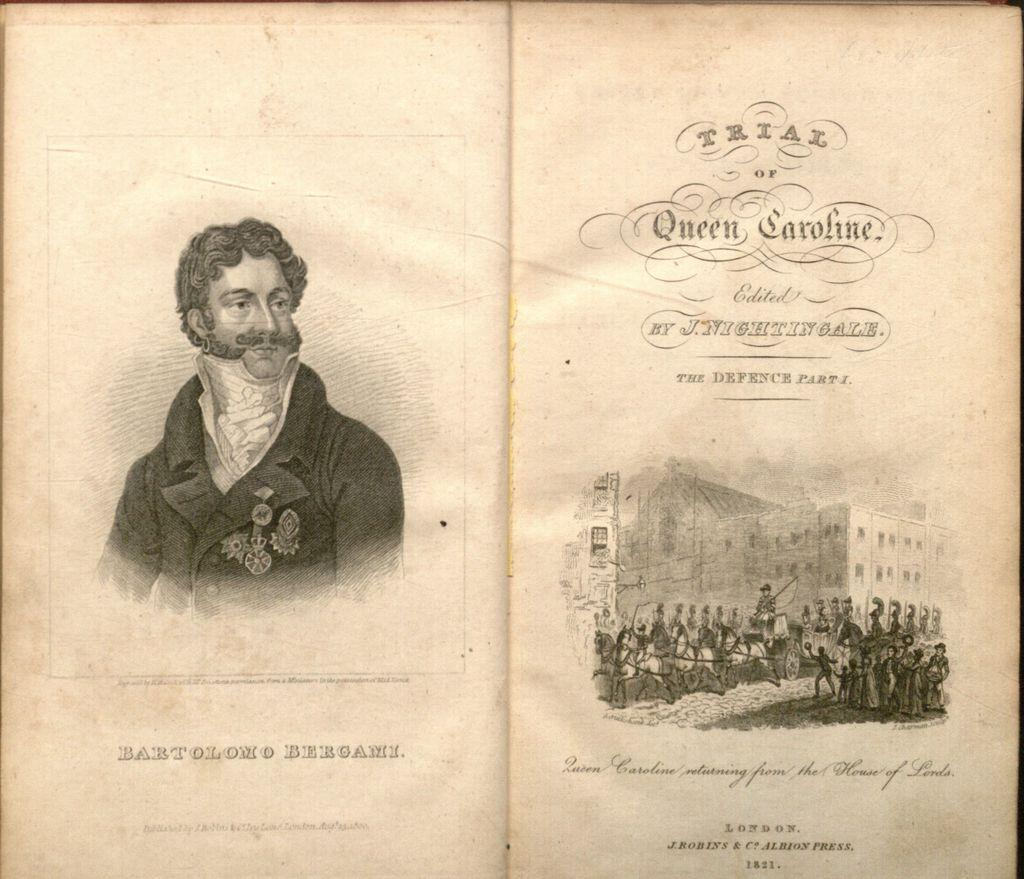What is located on the left side of the image? There is a person on the left side of the image. What can be seen on the right side of the image? There are people, trees, a vehicle, and a building on the right side of the image. How many people are visible in the image? There is at least one person on the left side and more people on the right side, so there are multiple people in the image. What type of structure is present on the right side of the image? There is a building on the right side of the image. What type of wool is being spun by the person on the left side of the image? There is no wool or spinning activity present in the image; it only shows a person on the left side and various elements on the right side. 